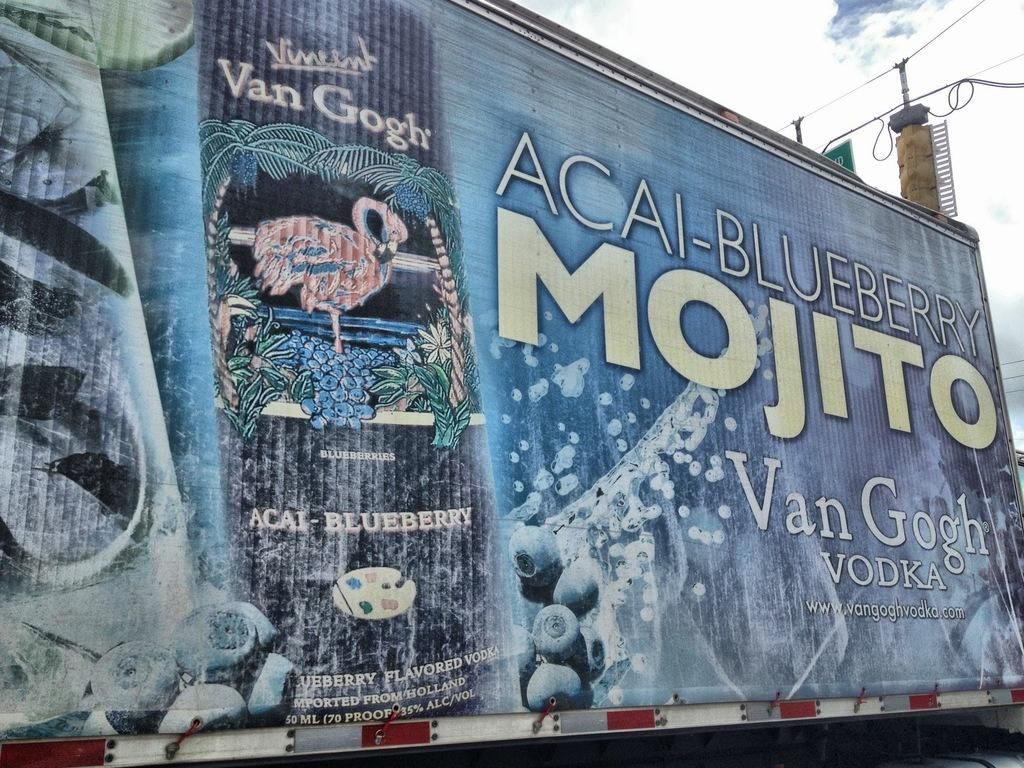<image>
Describe the image concisely. A large blueberry-colored banner advertises Van Gogh Vodka. 